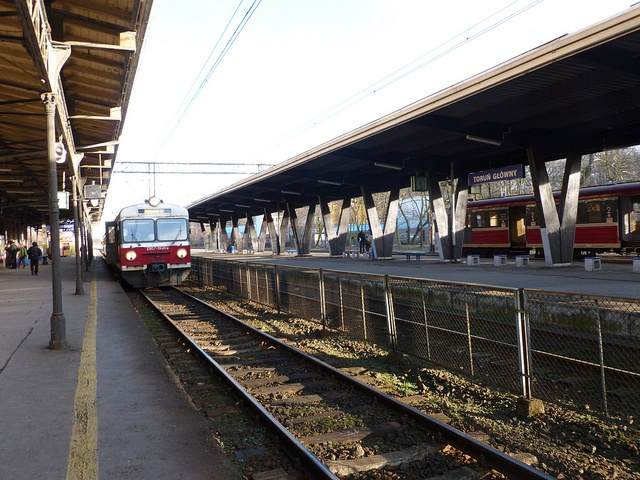Describe the objects in this image and their specific colors. I can see train in black, maroon, and gray tones, train in black, lightgray, lightblue, and maroon tones, people in black, gray, and tan tones, people in black, gray, maroon, and darkgreen tones, and people in black, gray, darkgreen, and navy tones in this image. 